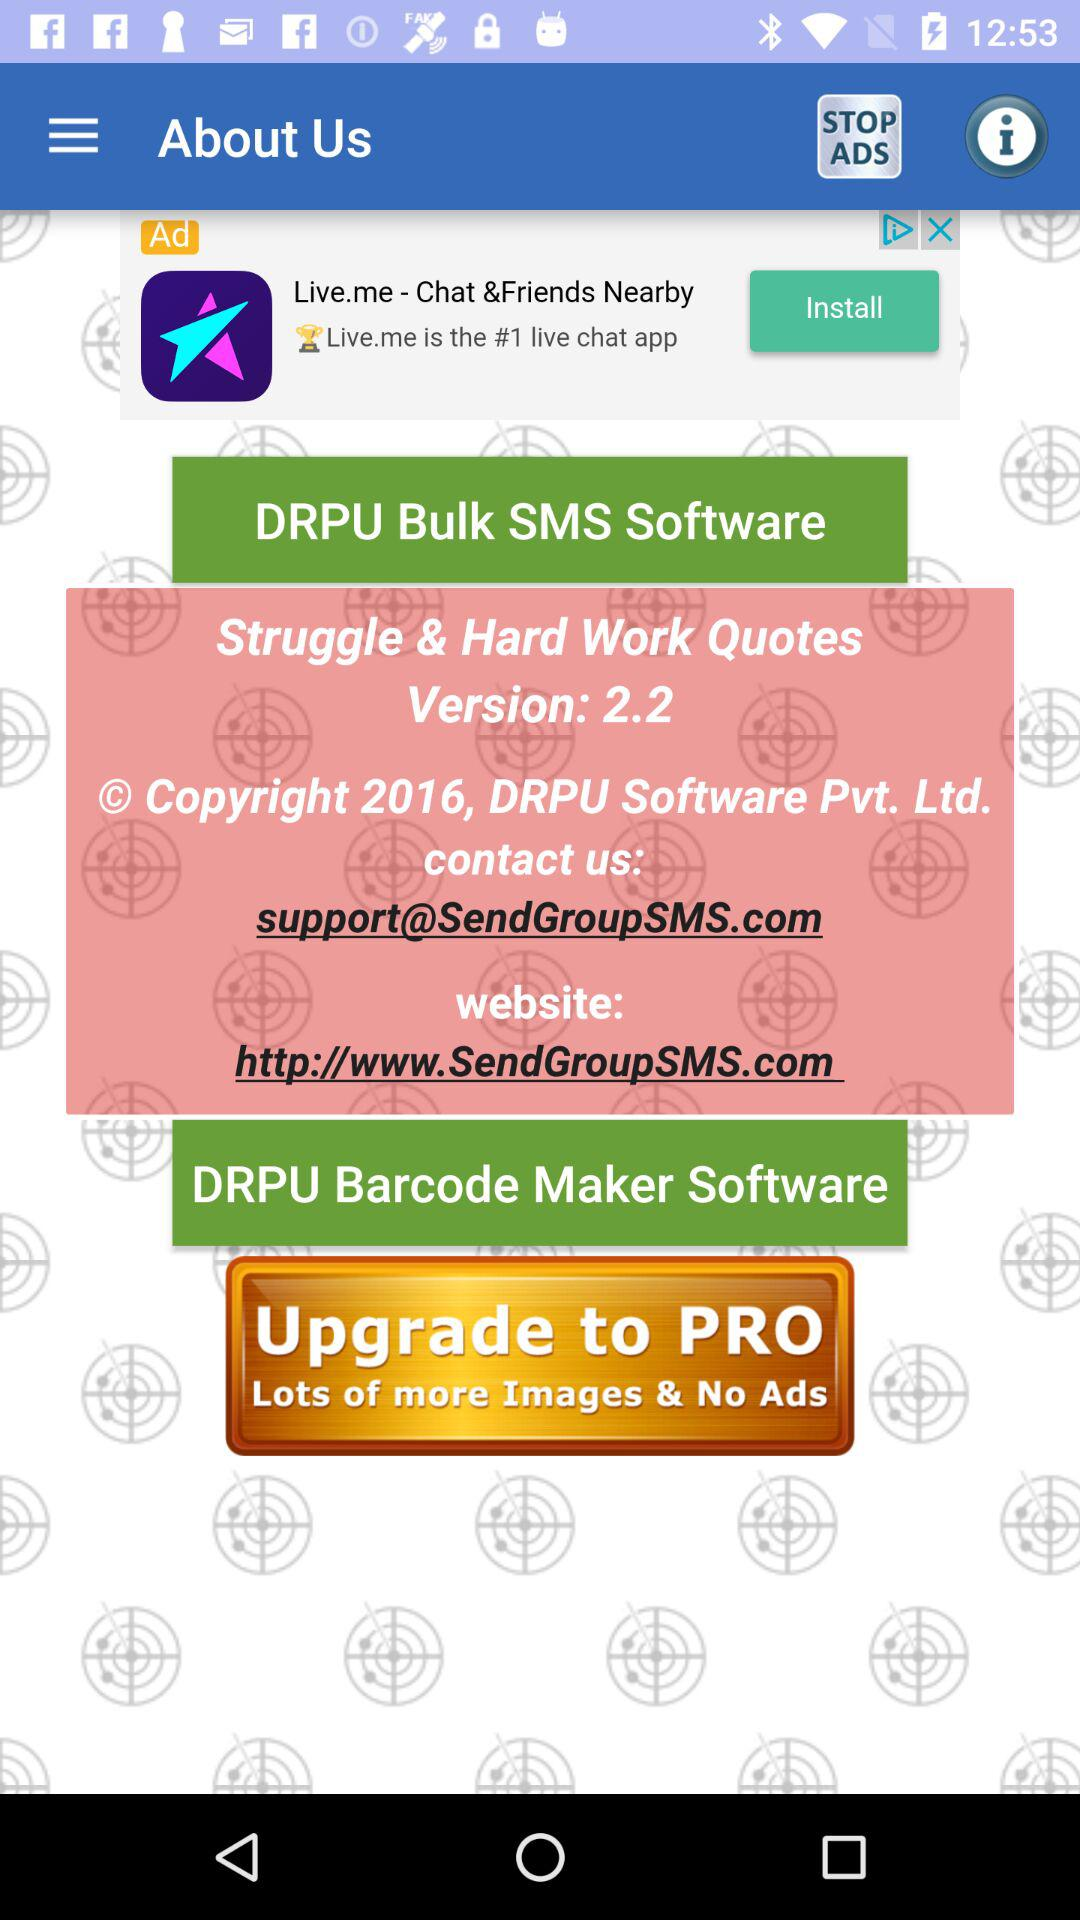What is the app name? The app name is "Struggle & Hard Work Quotes". 